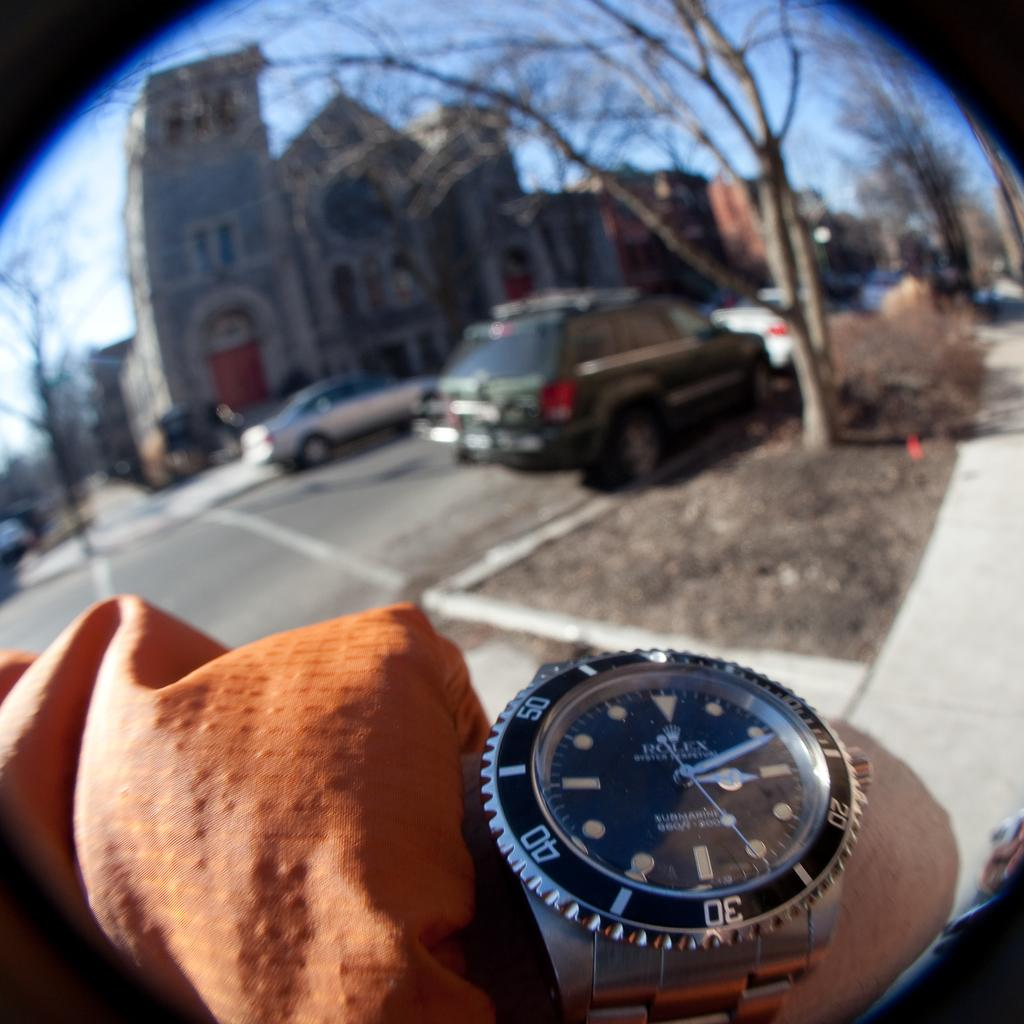<image>
Offer a succinct explanation of the picture presented. a person wearing a dark watch with the number 30 at the bottom 